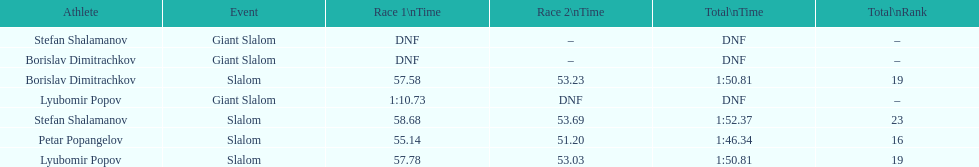Which athlete finished the first race but did not finish the second race? Lyubomir Popov. 